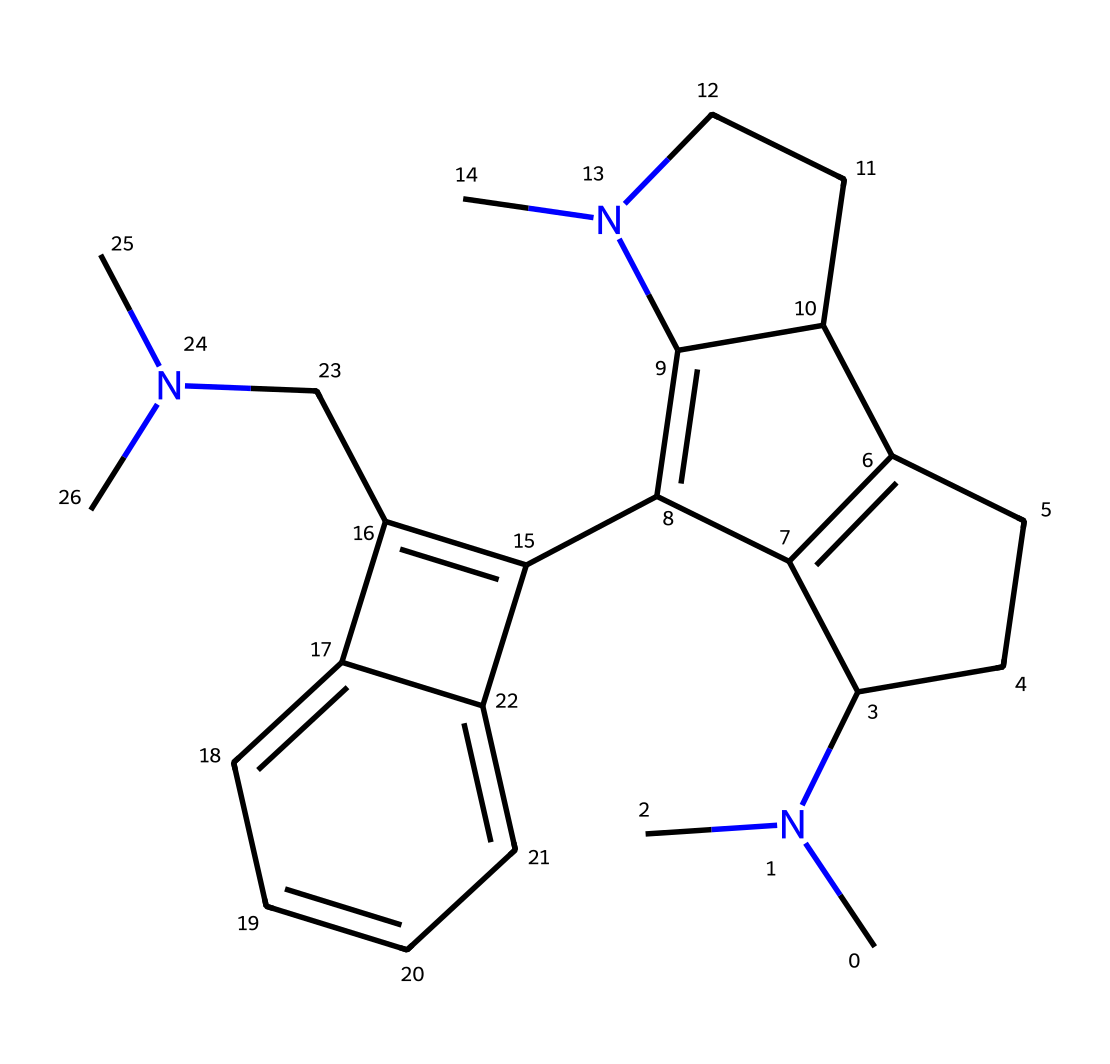What is the molecular formula of this compound? To find the molecular formula, we can count the number of each type of atom present in the SMILES representation. The structure contains several carbon (C), hydrogen (H), and nitrogen (N) atoms. Counting these gives us C16, H20, and N2, resulting in a molecular formula of C16H20N2.
Answer: C16H20N2 How many nitrogen atoms are present? By analyzing the SMILES, we can identify the occurrences of the nitrogen (N) atoms. The representation includes two nitrogen atoms in the structural formula.
Answer: 2 What functional groups are present in this chemical? The SMILES shows standard notations for a bicyclic organic compound with nitrogen atoms indicating that it is an alkaloid, specifically associated with a hallucinogen. Alkaloids typically contain amine groups due to the nitrogen atoms, which classify them with psychoactive properties.
Answer: amine Does this chemical likely act as an agonist or antagonist at serotonin receptors? Knowing that LSD mimics serotonin due to its structural similarity and specifically interacts at serotonin receptors optimally as an agonist, we infer that it primarily facilitates receptor activation. This aligns with its known psychoactive effects.
Answer: agonist Estimate the number of rings in the structure. By examining the SMILES string, we can determine the number of cyclic structures in the compound. The notation indicates multiple cycles are formed, visually confirming the presence of four rings based on the connections shown.
Answer: 4 Which section of the chemical is responsible for serotonin receptor interaction? The indole structure present in the compound’s arrangement is primarily recognized to interrelate with serotonin receptors. As LSD’s functional region, this portion facilitates the binding and interaction pivotal for activating the receptors.
Answer: indole structure 